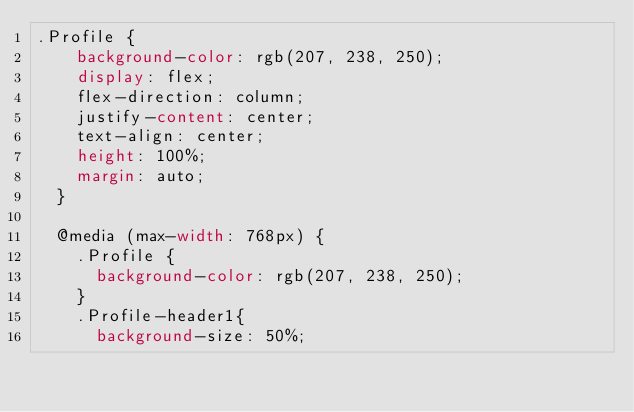<code> <loc_0><loc_0><loc_500><loc_500><_CSS_>.Profile {
    background-color: rgb(207, 238, 250);
    display: flex;
    flex-direction: column;
    justify-content: center;
    text-align: center;
    height: 100%;
    margin: auto;
  }
  
  @media (max-width: 768px) {  
    .Profile {
      background-color: rgb(207, 238, 250);
    }
    .Profile-header1{
      background-size: 50%;</code> 